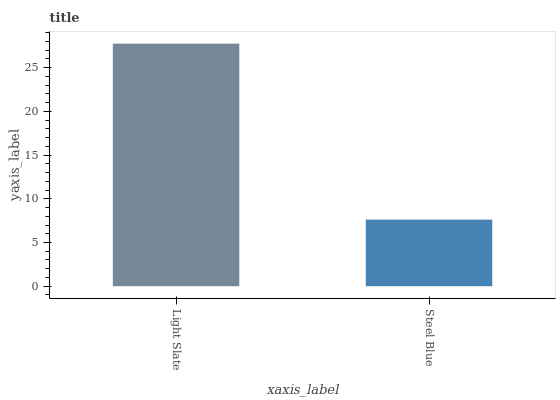Is Steel Blue the minimum?
Answer yes or no. Yes. Is Light Slate the maximum?
Answer yes or no. Yes. Is Steel Blue the maximum?
Answer yes or no. No. Is Light Slate greater than Steel Blue?
Answer yes or no. Yes. Is Steel Blue less than Light Slate?
Answer yes or no. Yes. Is Steel Blue greater than Light Slate?
Answer yes or no. No. Is Light Slate less than Steel Blue?
Answer yes or no. No. Is Light Slate the high median?
Answer yes or no. Yes. Is Steel Blue the low median?
Answer yes or no. Yes. Is Steel Blue the high median?
Answer yes or no. No. Is Light Slate the low median?
Answer yes or no. No. 